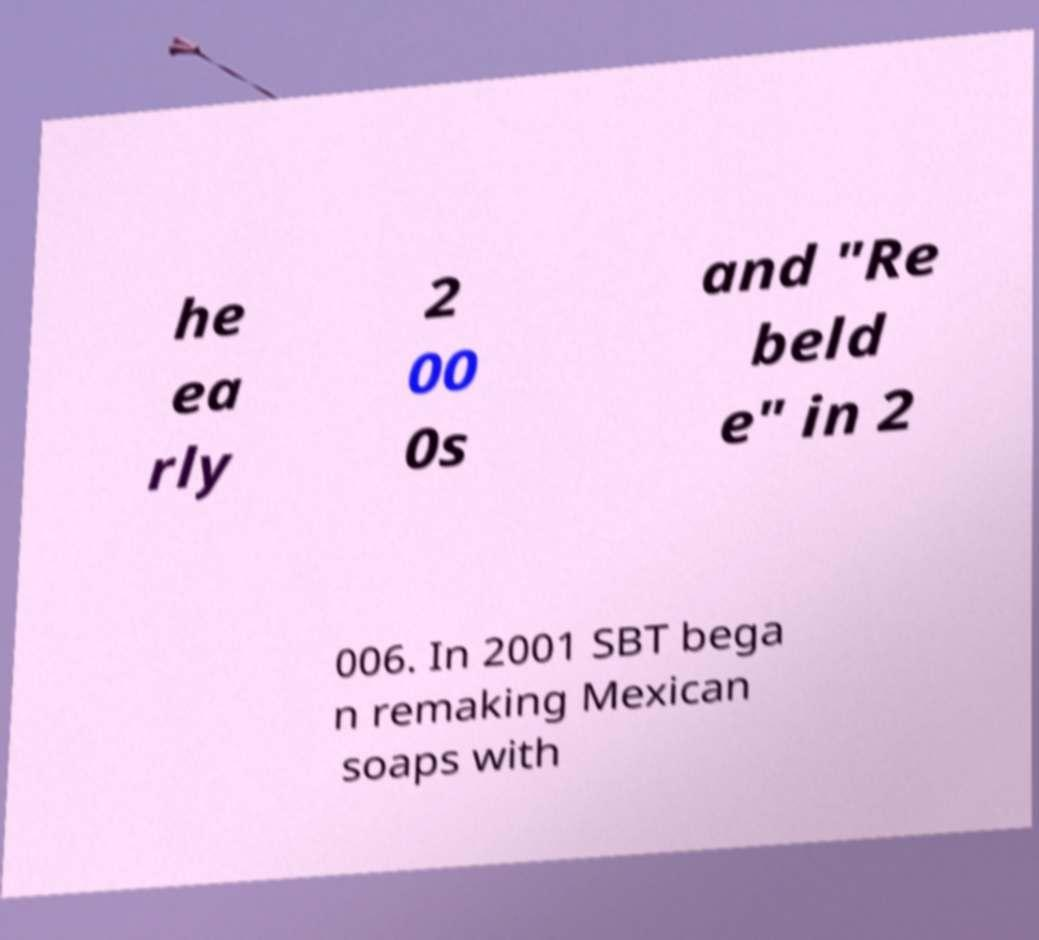Can you read and provide the text displayed in the image?This photo seems to have some interesting text. Can you extract and type it out for me? he ea rly 2 00 0s and "Re beld e" in 2 006. In 2001 SBT bega n remaking Mexican soaps with 